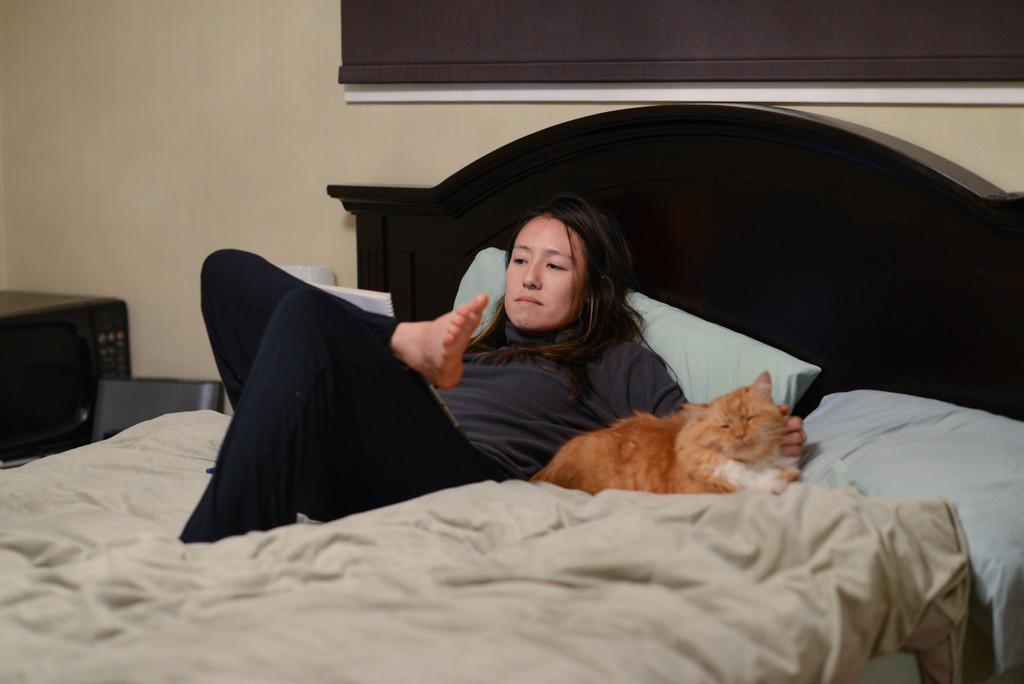What is the woman doing in the image? The woman is lying on the bed in the image. What other living creature is on the bed? There is a cat on the bed. What is used for support or comfort on the bed? There is a pillow on the bed. What type of appliance is located beside the bed? There is an oven beside the bed. What can be seen in the background of the image? There is a wall visible in the background. How many chickens are present on the tray in the image? There is no tray or chickens present in the image. 